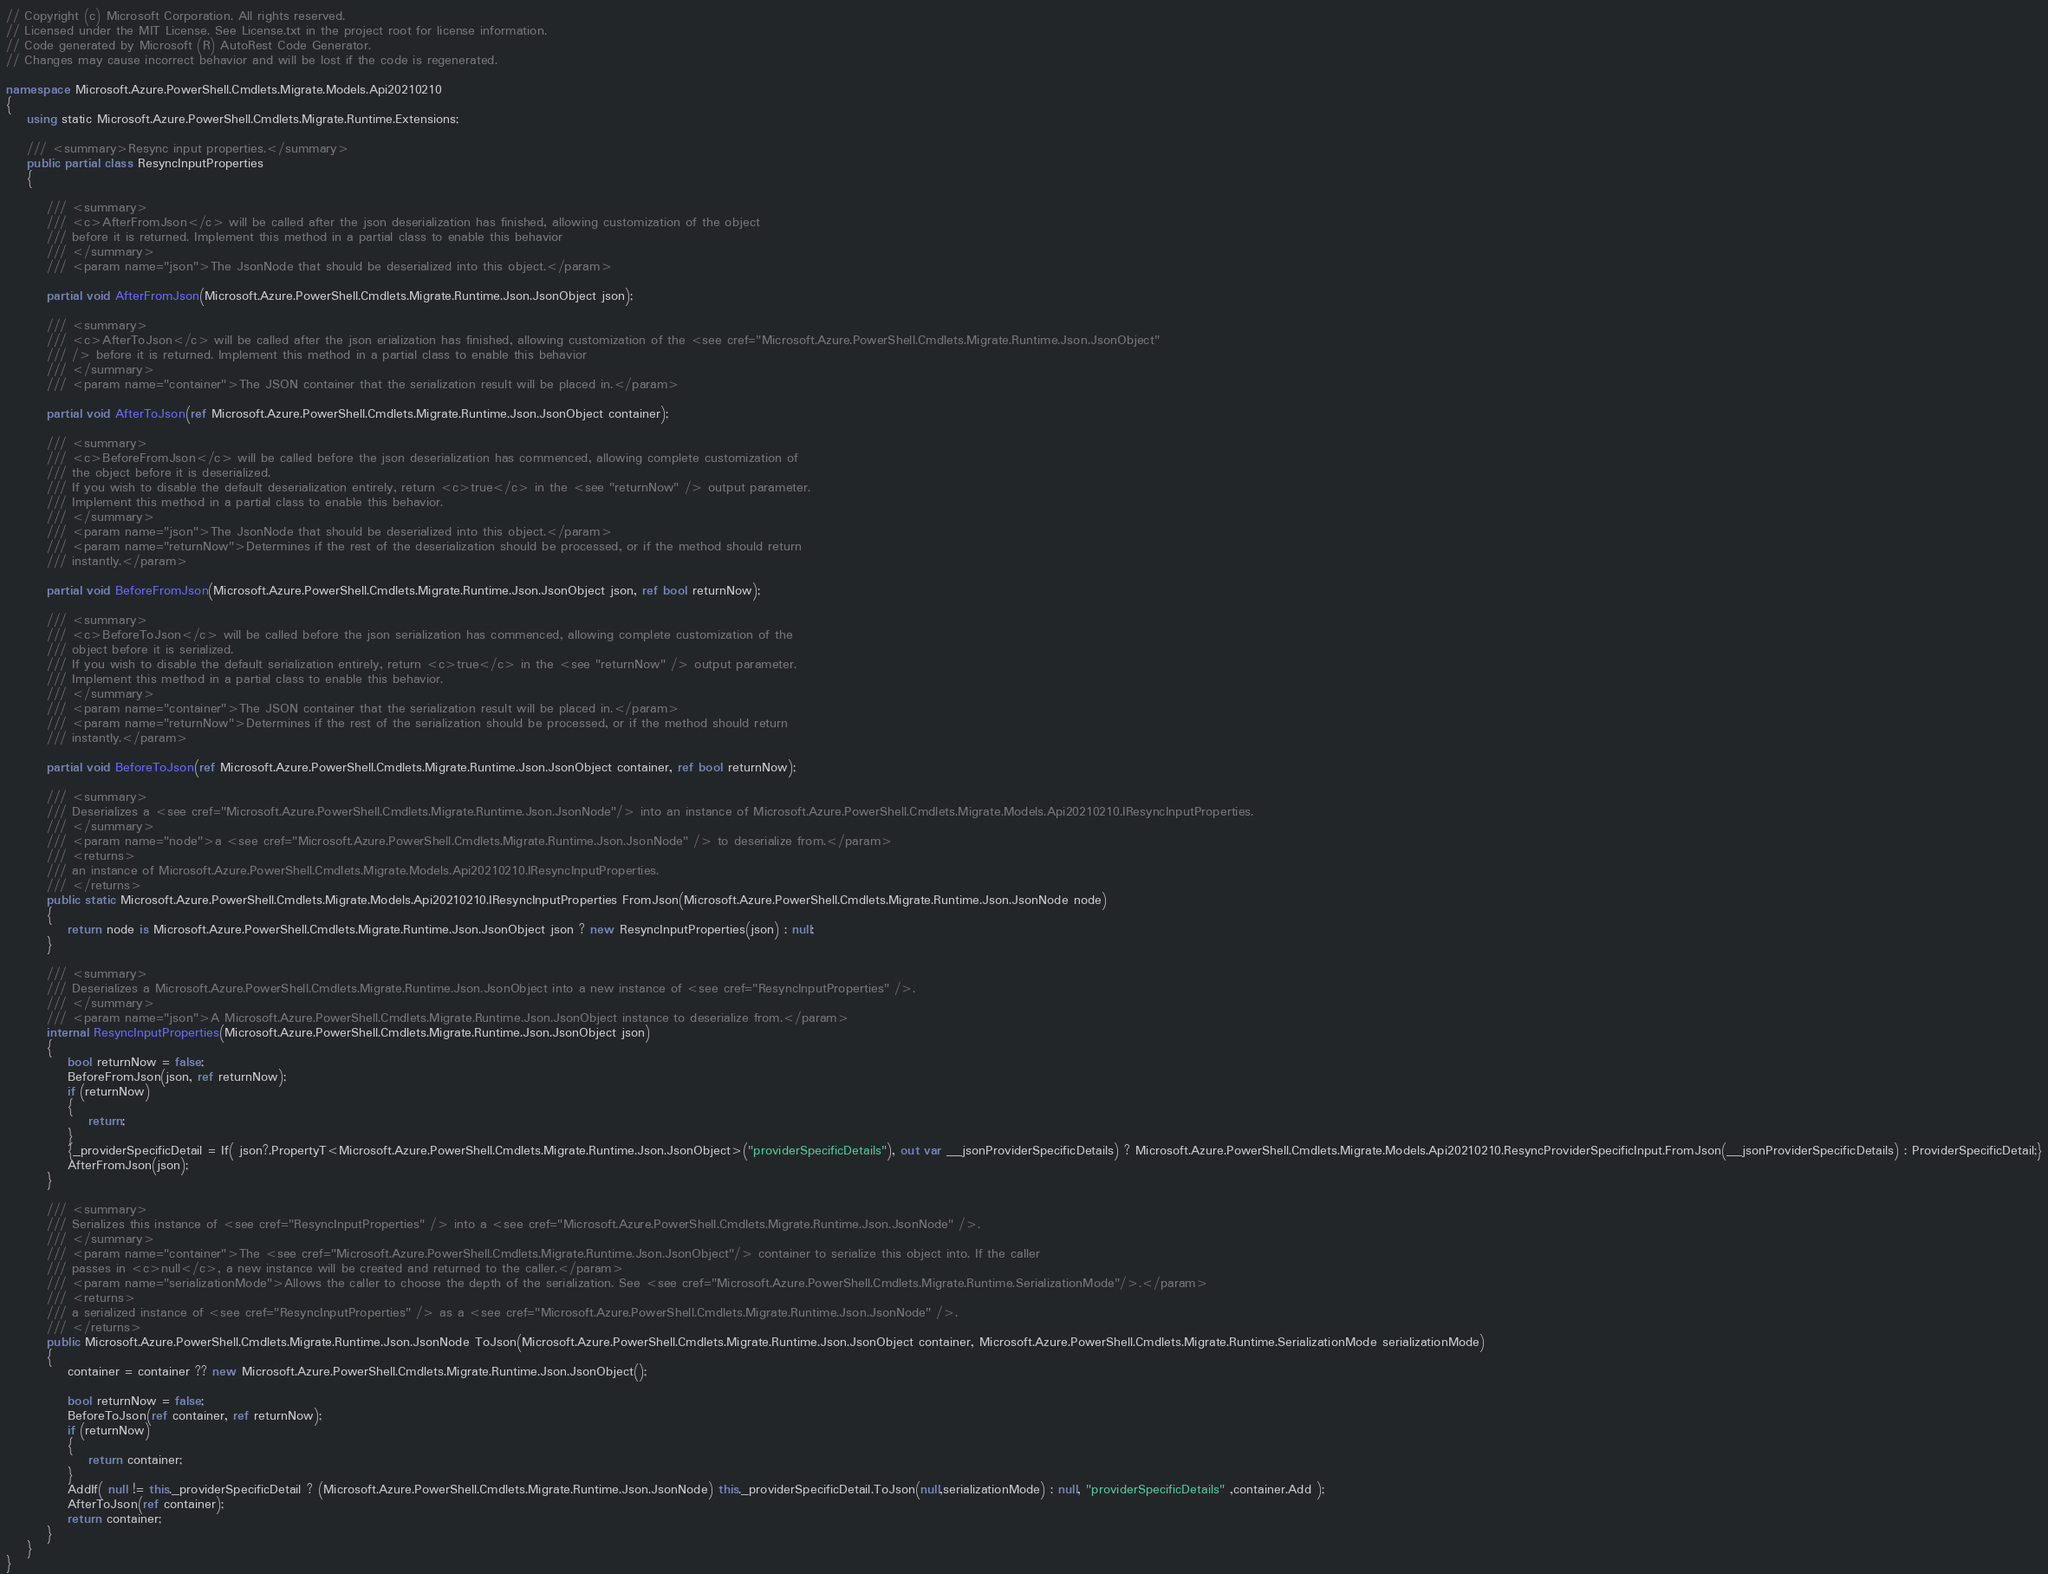<code> <loc_0><loc_0><loc_500><loc_500><_C#_>// Copyright (c) Microsoft Corporation. All rights reserved.
// Licensed under the MIT License. See License.txt in the project root for license information.
// Code generated by Microsoft (R) AutoRest Code Generator.
// Changes may cause incorrect behavior and will be lost if the code is regenerated.

namespace Microsoft.Azure.PowerShell.Cmdlets.Migrate.Models.Api20210210
{
    using static Microsoft.Azure.PowerShell.Cmdlets.Migrate.Runtime.Extensions;

    /// <summary>Resync input properties.</summary>
    public partial class ResyncInputProperties
    {

        /// <summary>
        /// <c>AfterFromJson</c> will be called after the json deserialization has finished, allowing customization of the object
        /// before it is returned. Implement this method in a partial class to enable this behavior
        /// </summary>
        /// <param name="json">The JsonNode that should be deserialized into this object.</param>

        partial void AfterFromJson(Microsoft.Azure.PowerShell.Cmdlets.Migrate.Runtime.Json.JsonObject json);

        /// <summary>
        /// <c>AfterToJson</c> will be called after the json erialization has finished, allowing customization of the <see cref="Microsoft.Azure.PowerShell.Cmdlets.Migrate.Runtime.Json.JsonObject"
        /// /> before it is returned. Implement this method in a partial class to enable this behavior
        /// </summary>
        /// <param name="container">The JSON container that the serialization result will be placed in.</param>

        partial void AfterToJson(ref Microsoft.Azure.PowerShell.Cmdlets.Migrate.Runtime.Json.JsonObject container);

        /// <summary>
        /// <c>BeforeFromJson</c> will be called before the json deserialization has commenced, allowing complete customization of
        /// the object before it is deserialized.
        /// If you wish to disable the default deserialization entirely, return <c>true</c> in the <see "returnNow" /> output parameter.
        /// Implement this method in a partial class to enable this behavior.
        /// </summary>
        /// <param name="json">The JsonNode that should be deserialized into this object.</param>
        /// <param name="returnNow">Determines if the rest of the deserialization should be processed, or if the method should return
        /// instantly.</param>

        partial void BeforeFromJson(Microsoft.Azure.PowerShell.Cmdlets.Migrate.Runtime.Json.JsonObject json, ref bool returnNow);

        /// <summary>
        /// <c>BeforeToJson</c> will be called before the json serialization has commenced, allowing complete customization of the
        /// object before it is serialized.
        /// If you wish to disable the default serialization entirely, return <c>true</c> in the <see "returnNow" /> output parameter.
        /// Implement this method in a partial class to enable this behavior.
        /// </summary>
        /// <param name="container">The JSON container that the serialization result will be placed in.</param>
        /// <param name="returnNow">Determines if the rest of the serialization should be processed, or if the method should return
        /// instantly.</param>

        partial void BeforeToJson(ref Microsoft.Azure.PowerShell.Cmdlets.Migrate.Runtime.Json.JsonObject container, ref bool returnNow);

        /// <summary>
        /// Deserializes a <see cref="Microsoft.Azure.PowerShell.Cmdlets.Migrate.Runtime.Json.JsonNode"/> into an instance of Microsoft.Azure.PowerShell.Cmdlets.Migrate.Models.Api20210210.IResyncInputProperties.
        /// </summary>
        /// <param name="node">a <see cref="Microsoft.Azure.PowerShell.Cmdlets.Migrate.Runtime.Json.JsonNode" /> to deserialize from.</param>
        /// <returns>
        /// an instance of Microsoft.Azure.PowerShell.Cmdlets.Migrate.Models.Api20210210.IResyncInputProperties.
        /// </returns>
        public static Microsoft.Azure.PowerShell.Cmdlets.Migrate.Models.Api20210210.IResyncInputProperties FromJson(Microsoft.Azure.PowerShell.Cmdlets.Migrate.Runtime.Json.JsonNode node)
        {
            return node is Microsoft.Azure.PowerShell.Cmdlets.Migrate.Runtime.Json.JsonObject json ? new ResyncInputProperties(json) : null;
        }

        /// <summary>
        /// Deserializes a Microsoft.Azure.PowerShell.Cmdlets.Migrate.Runtime.Json.JsonObject into a new instance of <see cref="ResyncInputProperties" />.
        /// </summary>
        /// <param name="json">A Microsoft.Azure.PowerShell.Cmdlets.Migrate.Runtime.Json.JsonObject instance to deserialize from.</param>
        internal ResyncInputProperties(Microsoft.Azure.PowerShell.Cmdlets.Migrate.Runtime.Json.JsonObject json)
        {
            bool returnNow = false;
            BeforeFromJson(json, ref returnNow);
            if (returnNow)
            {
                return;
            }
            {_providerSpecificDetail = If( json?.PropertyT<Microsoft.Azure.PowerShell.Cmdlets.Migrate.Runtime.Json.JsonObject>("providerSpecificDetails"), out var __jsonProviderSpecificDetails) ? Microsoft.Azure.PowerShell.Cmdlets.Migrate.Models.Api20210210.ResyncProviderSpecificInput.FromJson(__jsonProviderSpecificDetails) : ProviderSpecificDetail;}
            AfterFromJson(json);
        }

        /// <summary>
        /// Serializes this instance of <see cref="ResyncInputProperties" /> into a <see cref="Microsoft.Azure.PowerShell.Cmdlets.Migrate.Runtime.Json.JsonNode" />.
        /// </summary>
        /// <param name="container">The <see cref="Microsoft.Azure.PowerShell.Cmdlets.Migrate.Runtime.Json.JsonObject"/> container to serialize this object into. If the caller
        /// passes in <c>null</c>, a new instance will be created and returned to the caller.</param>
        /// <param name="serializationMode">Allows the caller to choose the depth of the serialization. See <see cref="Microsoft.Azure.PowerShell.Cmdlets.Migrate.Runtime.SerializationMode"/>.</param>
        /// <returns>
        /// a serialized instance of <see cref="ResyncInputProperties" /> as a <see cref="Microsoft.Azure.PowerShell.Cmdlets.Migrate.Runtime.Json.JsonNode" />.
        /// </returns>
        public Microsoft.Azure.PowerShell.Cmdlets.Migrate.Runtime.Json.JsonNode ToJson(Microsoft.Azure.PowerShell.Cmdlets.Migrate.Runtime.Json.JsonObject container, Microsoft.Azure.PowerShell.Cmdlets.Migrate.Runtime.SerializationMode serializationMode)
        {
            container = container ?? new Microsoft.Azure.PowerShell.Cmdlets.Migrate.Runtime.Json.JsonObject();

            bool returnNow = false;
            BeforeToJson(ref container, ref returnNow);
            if (returnNow)
            {
                return container;
            }
            AddIf( null != this._providerSpecificDetail ? (Microsoft.Azure.PowerShell.Cmdlets.Migrate.Runtime.Json.JsonNode) this._providerSpecificDetail.ToJson(null,serializationMode) : null, "providerSpecificDetails" ,container.Add );
            AfterToJson(ref container);
            return container;
        }
    }
}</code> 